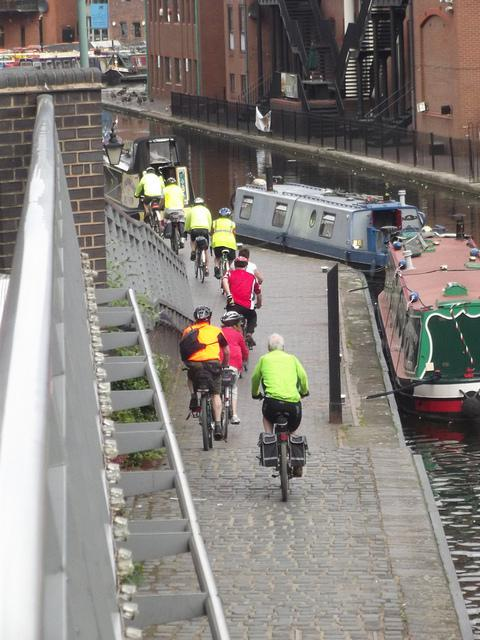Why are some cyclists wearing yellow?

Choices:
A) uniform
B) costume
C) visibility
D) style visibility 